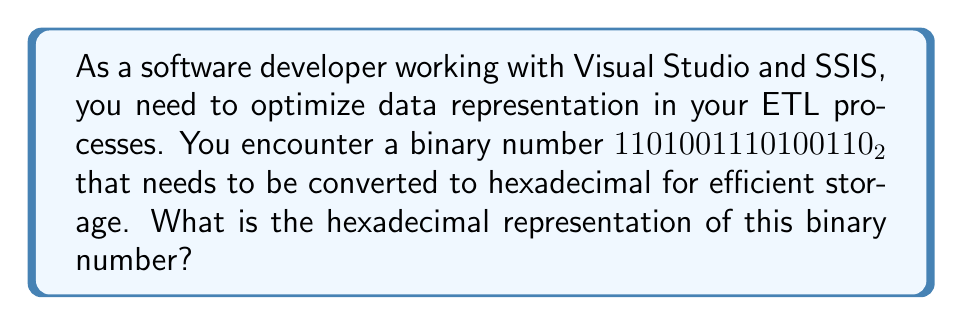Can you answer this question? To convert a binary number to hexadecimal, we can follow these steps:

1. Group the binary digits into sets of 4, starting from the right:
   $$1101 0011 1010 0110_2$$

2. Convert each group of 4 binary digits to its hexadecimal equivalent:

   For $1101_2$:
   $$1\cdot2^3 + 1\cdot2^2 + 0\cdot2^1 + 1\cdot2^0 = 8 + 4 + 0 + 1 = 13 = \text{D}_{16}$$

   For $0011_2$:
   $$0\cdot2^3 + 0\cdot2^2 + 1\cdot2^1 + 1\cdot2^0 = 0 + 0 + 2 + 1 = 3 = \text{3}_{16}$$

   For $1010_2$:
   $$1\cdot2^3 + 0\cdot2^2 + 1\cdot2^1 + 0\cdot2^0 = 8 + 0 + 2 + 0 = 10 = \text{A}_{16}$$

   For $0110_2$:
   $$0\cdot2^3 + 1\cdot2^2 + 1\cdot2^1 + 0\cdot2^0 = 0 + 4 + 2 + 0 = 6 = \text{6}_{16}$$

3. Combine the hexadecimal digits in the same order:
   $$\text{D3A6}_{16}$$

This conversion allows for more compact representation of the data, which can be beneficial in SSIS packages for efficient data transfer and storage.
Answer: $\text{D3A6}_{16}$ 